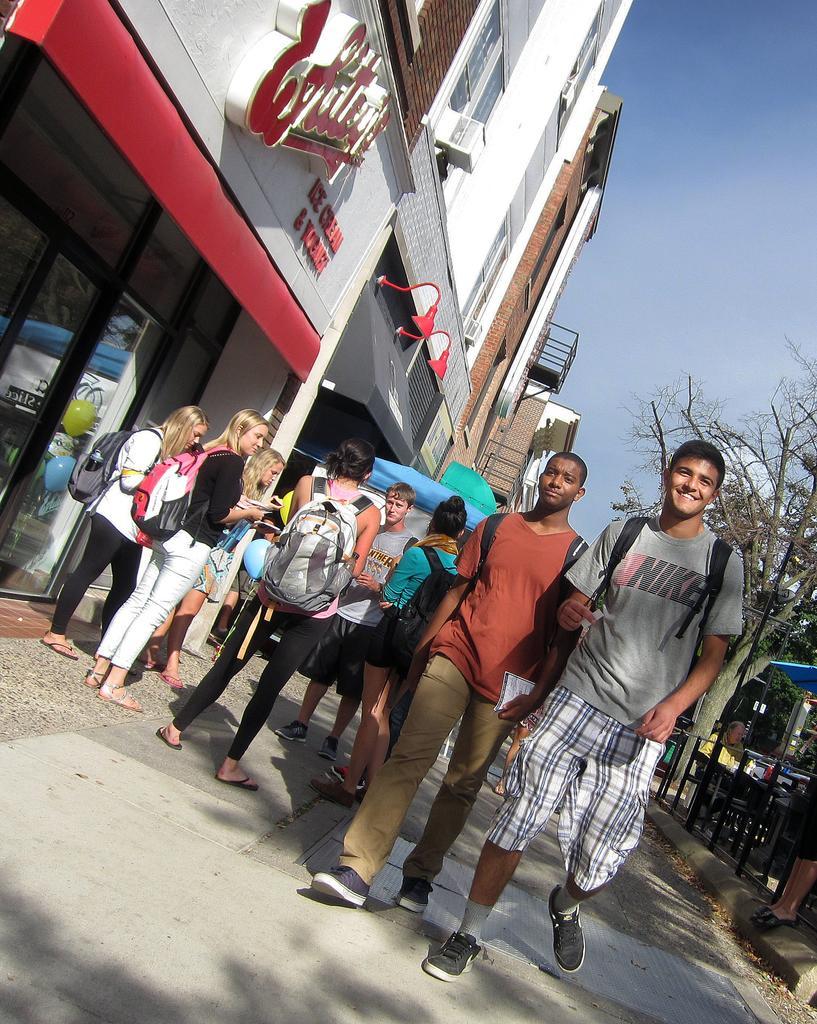In one or two sentences, can you explain what this image depicts? This image is clicked on the road. There are two men walking and a few people standing on the road. To the right there are chairs, trees, a pole, a table umbrella and a railing. In the top left there are buildings. There are lights, windows and text on the walls of the building. To the left there are glass doors to the building. In the top right there is the sky. 